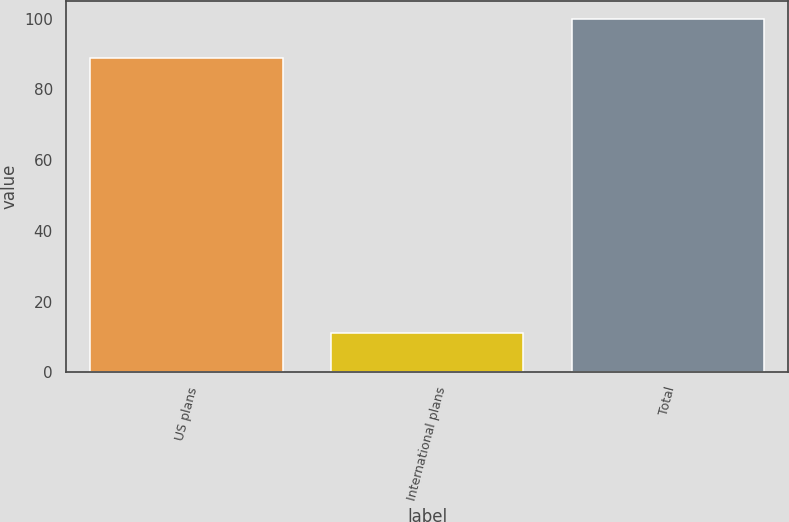Convert chart. <chart><loc_0><loc_0><loc_500><loc_500><bar_chart><fcel>US plans<fcel>International plans<fcel>Total<nl><fcel>89<fcel>11<fcel>100<nl></chart> 